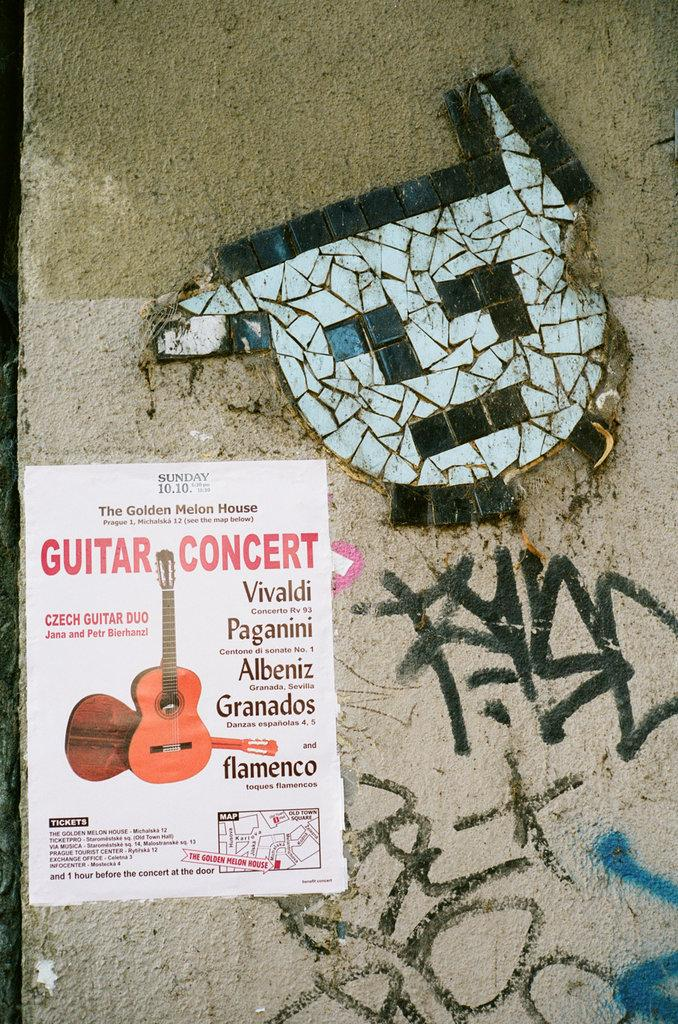<image>
Share a concise interpretation of the image provided. A poster on a grafiti filled wall advertises a Guitar Concert. 